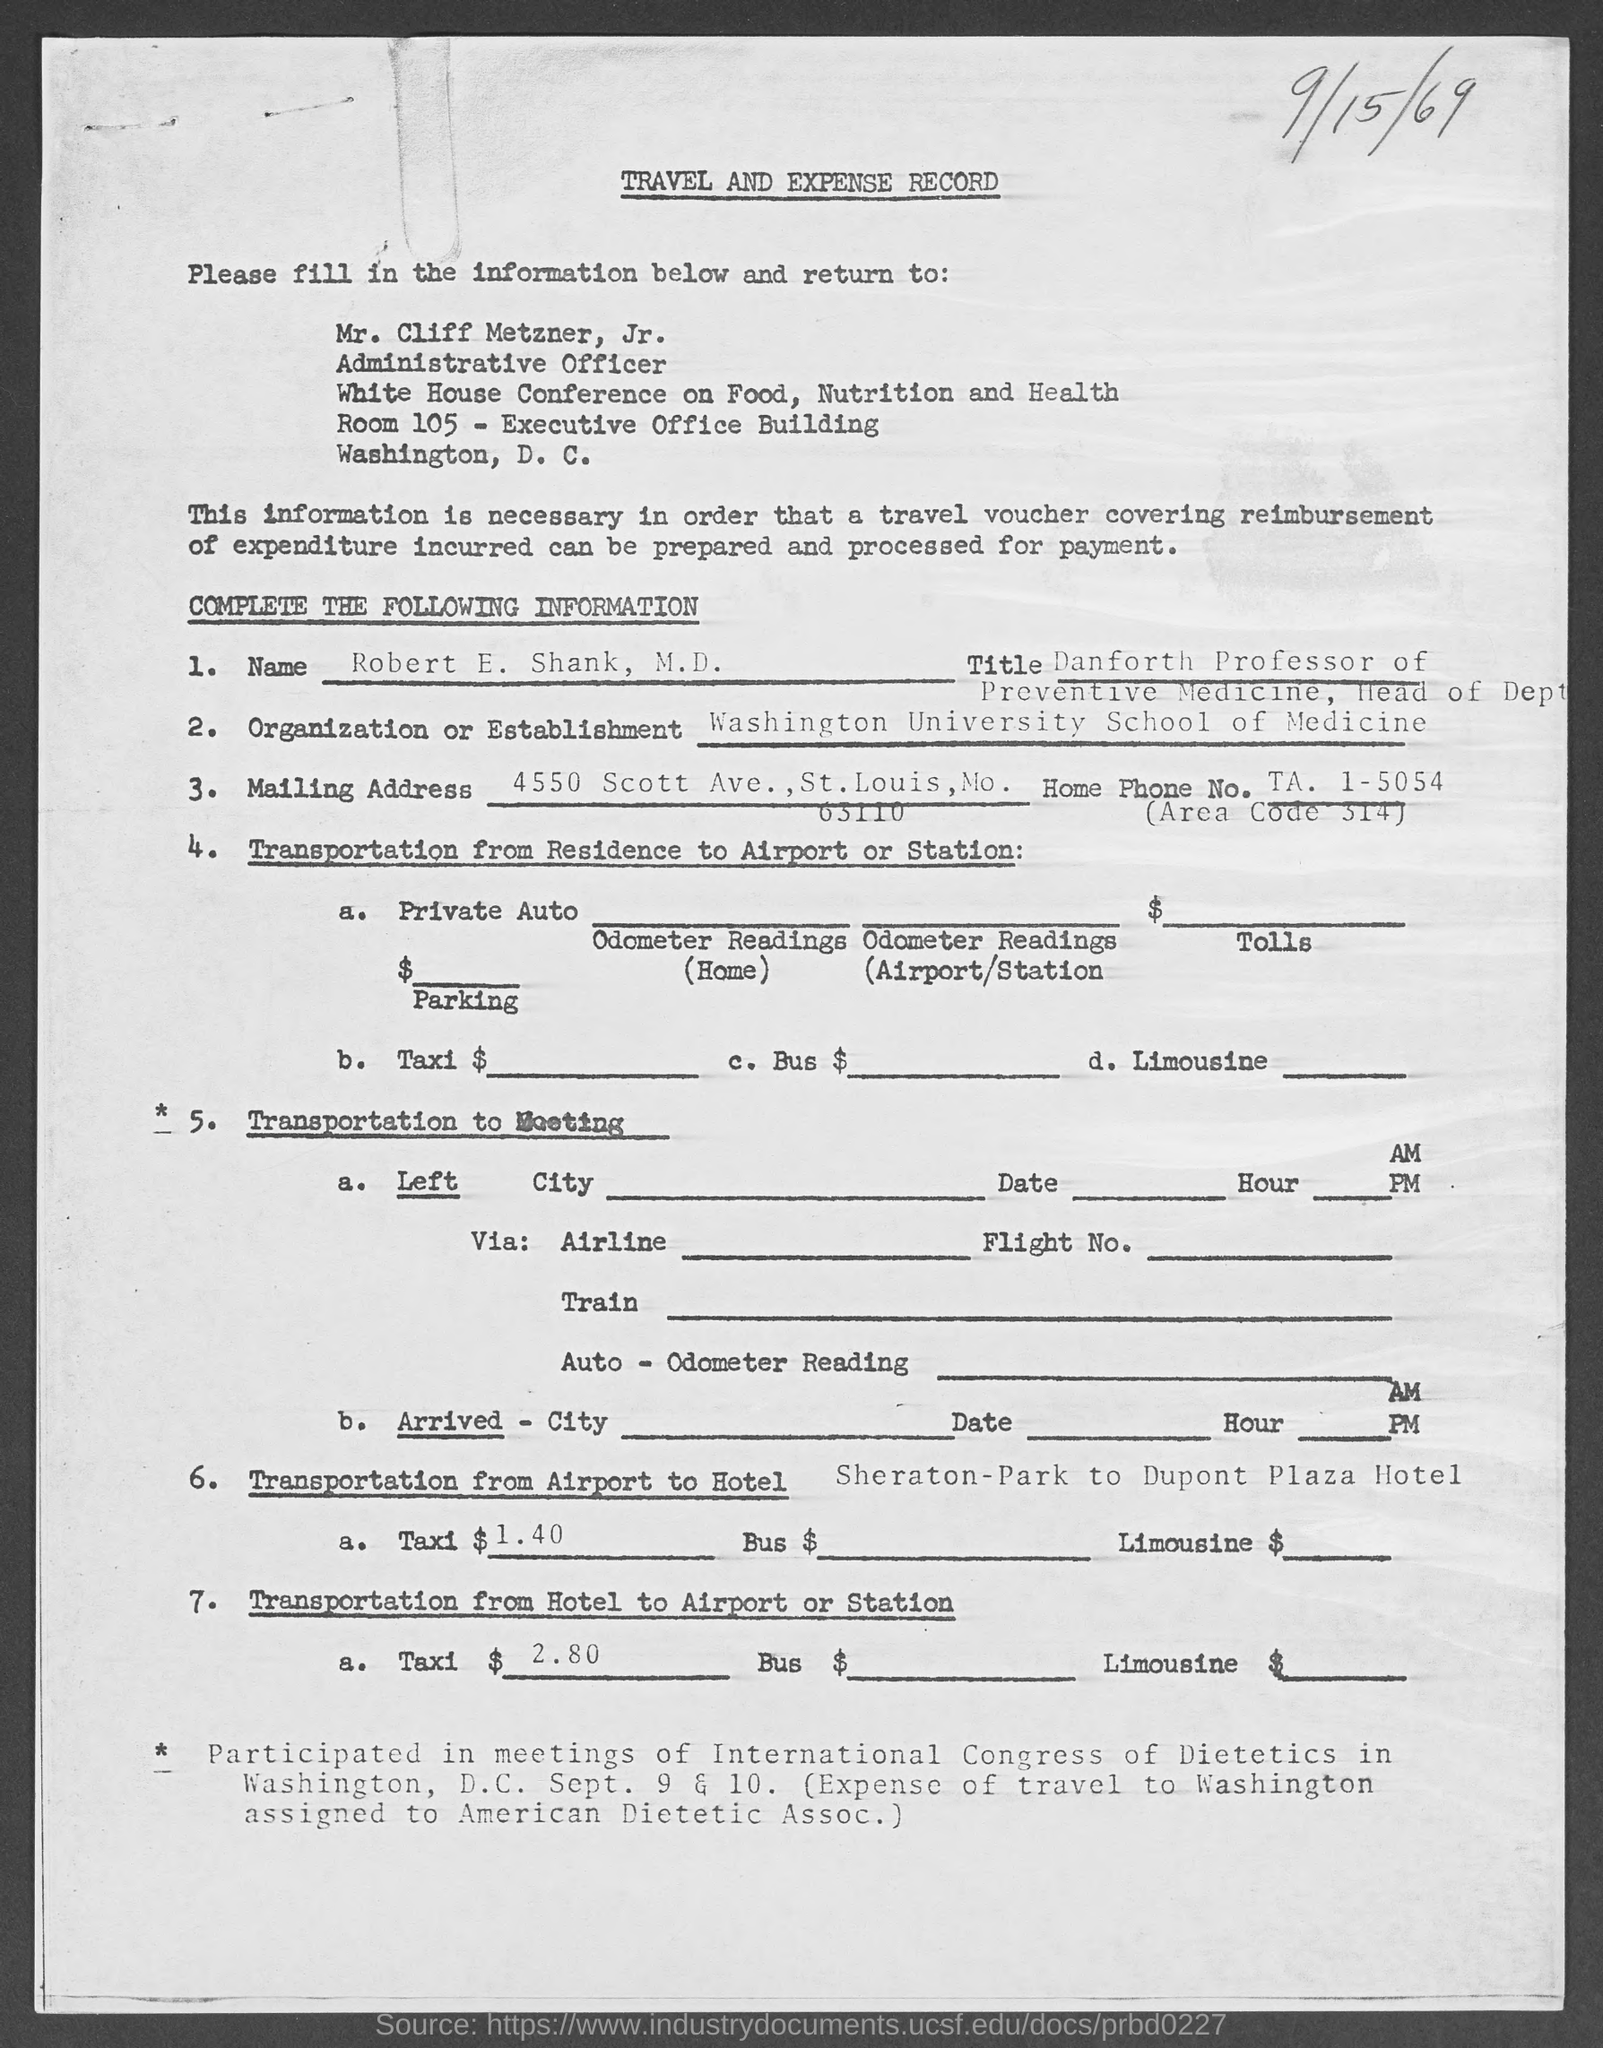Outline some significant characteristics in this image. The position of Mr. Cliff Metzner, Jr. is an administrative officer. The name of the applicant is Robert E. Shank, M.D. 